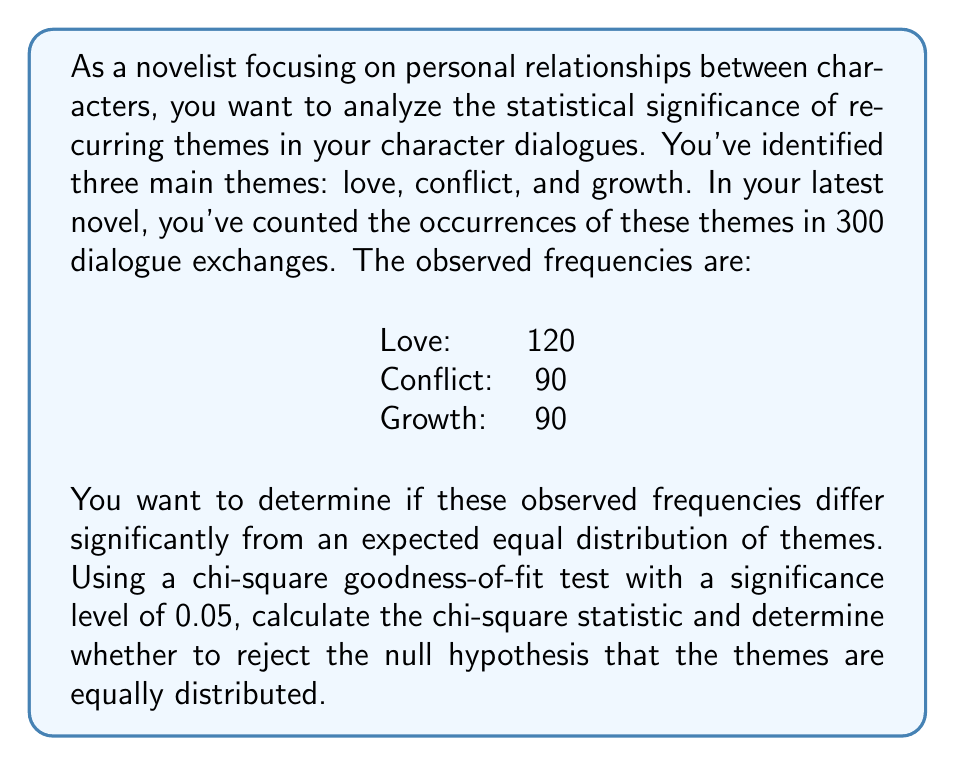Can you answer this question? To solve this problem, we'll use the chi-square goodness-of-fit test. This test is appropriate when we want to compare observed frequencies to expected frequencies under a null hypothesis.

Step 1: State the null and alternative hypotheses
$H_0$: The themes are equally distributed (Love = Conflict = Growth)
$H_a$: The themes are not equally distributed

Step 2: Calculate the expected frequencies
Total dialogues = 120 + 90 + 90 = 300
Expected frequency for each theme = 300 / 3 = 100

Step 3: Calculate the chi-square statistic
The formula for the chi-square statistic is:

$$ \chi^2 = \sum_{i=1}^{k} \frac{(O_i - E_i)^2}{E_i} $$

Where:
$O_i$ = Observed frequency
$E_i$ = Expected frequency
$k$ = Number of categories

Calculating for each theme:
Love: $\frac{(120 - 100)^2}{100} = 4$
Conflict: $\frac{(90 - 100)^2}{100} = 1$
Growth: $\frac{(90 - 100)^2}{100} = 1$

$\chi^2 = 4 + 1 + 1 = 6$

Step 4: Determine the critical value
Degrees of freedom (df) = k - 1 = 3 - 1 = 2
For α = 0.05 and df = 2, the critical value is 5.99 (from a chi-square distribution table)

Step 5: Compare the calculated chi-square value to the critical value
Since 6 > 5.99, we reject the null hypothesis.

Step 6: Interpret the results
There is sufficient evidence to conclude that the themes are not equally distributed in the character dialogues. The difference in frequencies is statistically significant at the 0.05 level.
Answer: The chi-square statistic is 6. Since this value is greater than the critical value of 5.99 (at α = 0.05 with df = 2), we reject the null hypothesis. There is a statistically significant difference in the distribution of themes in the character dialogues. 